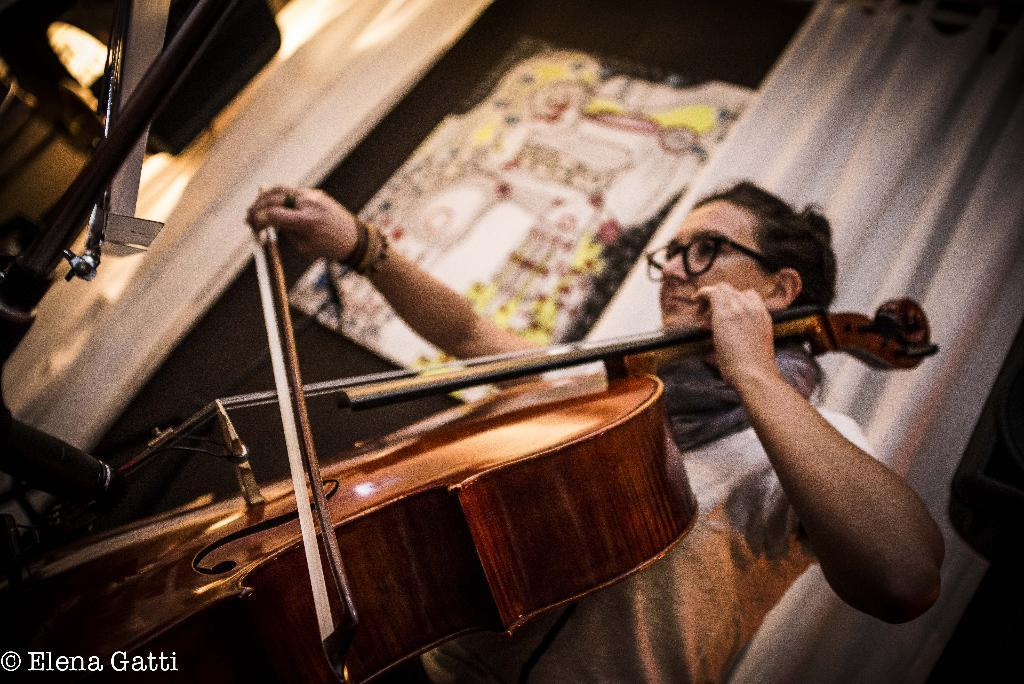What is the woman in the image doing? The woman is playing a guitar in the image. What is the woman wearing? The woman is wearing a white shirt in the image. What can be seen in the background of the image? There is a white curtain and a black door in the background, along with musical instruments. What type of boat can be seen in the image? There is no boat present in the image. 